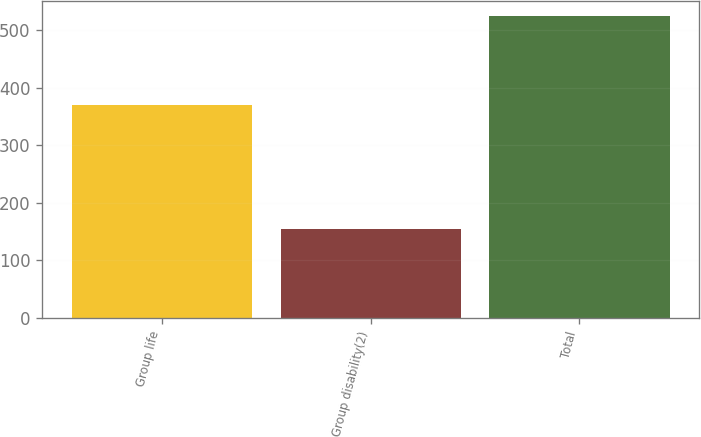<chart> <loc_0><loc_0><loc_500><loc_500><bar_chart><fcel>Group life<fcel>Group disability(2)<fcel>Total<nl><fcel>370<fcel>154<fcel>524<nl></chart> 